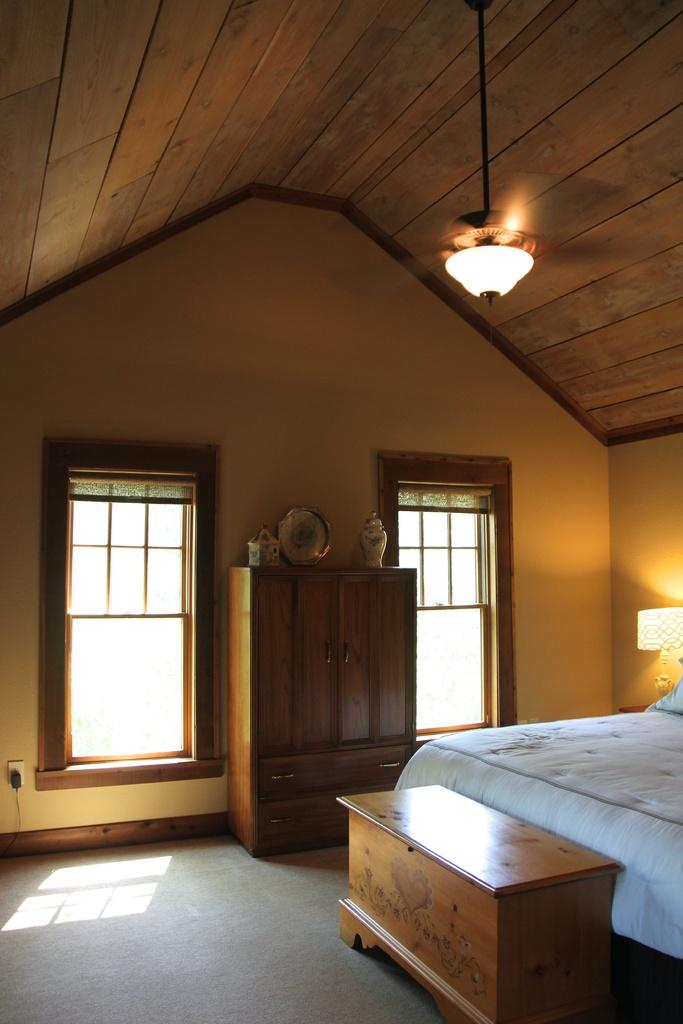What type of furniture is present in the image? There is a bed in the image. What can be used for illumination in the image? There is a light in the image. What type of storage furniture is present in the image? There is an almirah in the image. What allows natural light to enter the room in the image? There are windows in the image. How many faucets are present in the image? There is no faucet present in the image. Can you describe the snail's habitat in the image? There is no snail present in the image. 